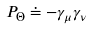Convert formula to latex. <formula><loc_0><loc_0><loc_500><loc_500>P _ { \Theta } \doteq - \gamma _ { \mu } \gamma _ { \nu }</formula> 